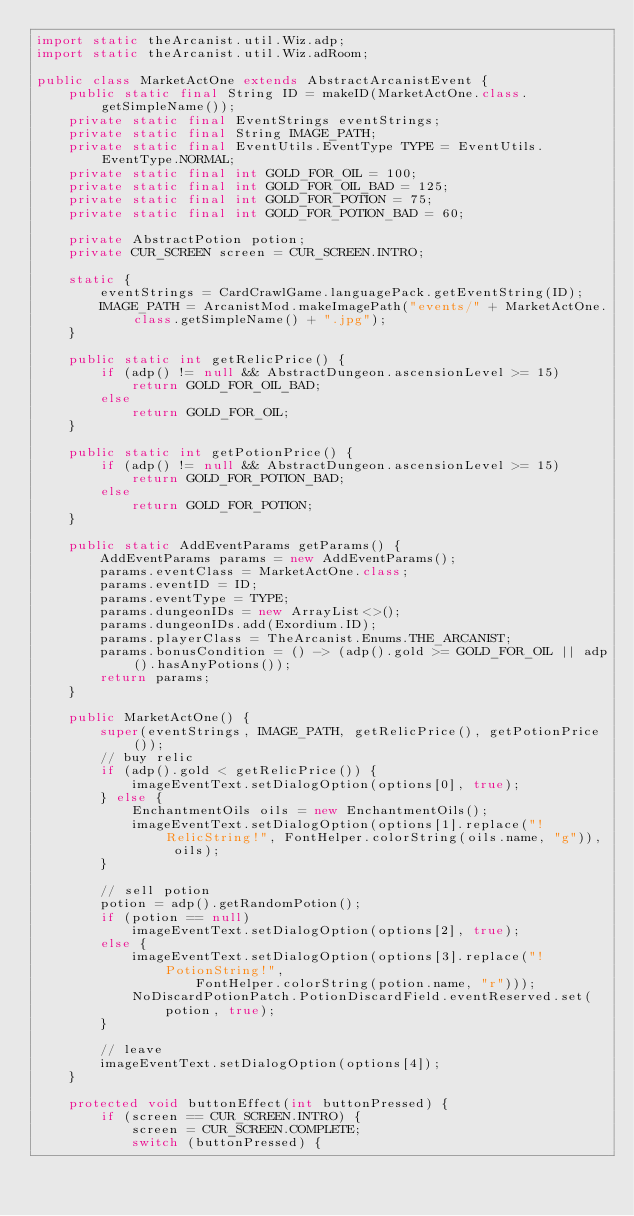Convert code to text. <code><loc_0><loc_0><loc_500><loc_500><_Java_>import static theArcanist.util.Wiz.adp;
import static theArcanist.util.Wiz.adRoom;

public class MarketActOne extends AbstractArcanistEvent {
    public static final String ID = makeID(MarketActOne.class.getSimpleName());
    private static final EventStrings eventStrings;
    private static final String IMAGE_PATH;
    private static final EventUtils.EventType TYPE = EventUtils.EventType.NORMAL;
    private static final int GOLD_FOR_OIL = 100;
    private static final int GOLD_FOR_OIL_BAD = 125;
    private static final int GOLD_FOR_POTION = 75;
    private static final int GOLD_FOR_POTION_BAD = 60;

    private AbstractPotion potion;
    private CUR_SCREEN screen = CUR_SCREEN.INTRO;

    static {
        eventStrings = CardCrawlGame.languagePack.getEventString(ID);
        IMAGE_PATH = ArcanistMod.makeImagePath("events/" + MarketActOne.class.getSimpleName() + ".jpg");
    }

    public static int getRelicPrice() {
        if (adp() != null && AbstractDungeon.ascensionLevel >= 15)
            return GOLD_FOR_OIL_BAD;
        else
            return GOLD_FOR_OIL;
    }

    public static int getPotionPrice() {
        if (adp() != null && AbstractDungeon.ascensionLevel >= 15)
            return GOLD_FOR_POTION_BAD;
        else
            return GOLD_FOR_POTION;
    }

    public static AddEventParams getParams() {
        AddEventParams params = new AddEventParams();
        params.eventClass = MarketActOne.class;
        params.eventID = ID;
        params.eventType = TYPE;
        params.dungeonIDs = new ArrayList<>();
        params.dungeonIDs.add(Exordium.ID);
        params.playerClass = TheArcanist.Enums.THE_ARCANIST;
        params.bonusCondition = () -> (adp().gold >= GOLD_FOR_OIL || adp().hasAnyPotions());
        return params;
    }

    public MarketActOne() {
        super(eventStrings, IMAGE_PATH, getRelicPrice(), getPotionPrice());
        // buy relic
        if (adp().gold < getRelicPrice()) {
            imageEventText.setDialogOption(options[0], true);
        } else {
            EnchantmentOils oils = new EnchantmentOils();
            imageEventText.setDialogOption(options[1].replace("!RelicString!", FontHelper.colorString(oils.name, "g")), oils);
        }

        // sell potion
        potion = adp().getRandomPotion();
        if (potion == null)
            imageEventText.setDialogOption(options[2], true);
        else {
            imageEventText.setDialogOption(options[3].replace("!PotionString!",
                    FontHelper.colorString(potion.name, "r")));
            NoDiscardPotionPatch.PotionDiscardField.eventReserved.set(potion, true);
        }

        // leave
        imageEventText.setDialogOption(options[4]);
    }

    protected void buttonEffect(int buttonPressed) {
        if (screen == CUR_SCREEN.INTRO) {
            screen = CUR_SCREEN.COMPLETE;
            switch (buttonPressed) {</code> 